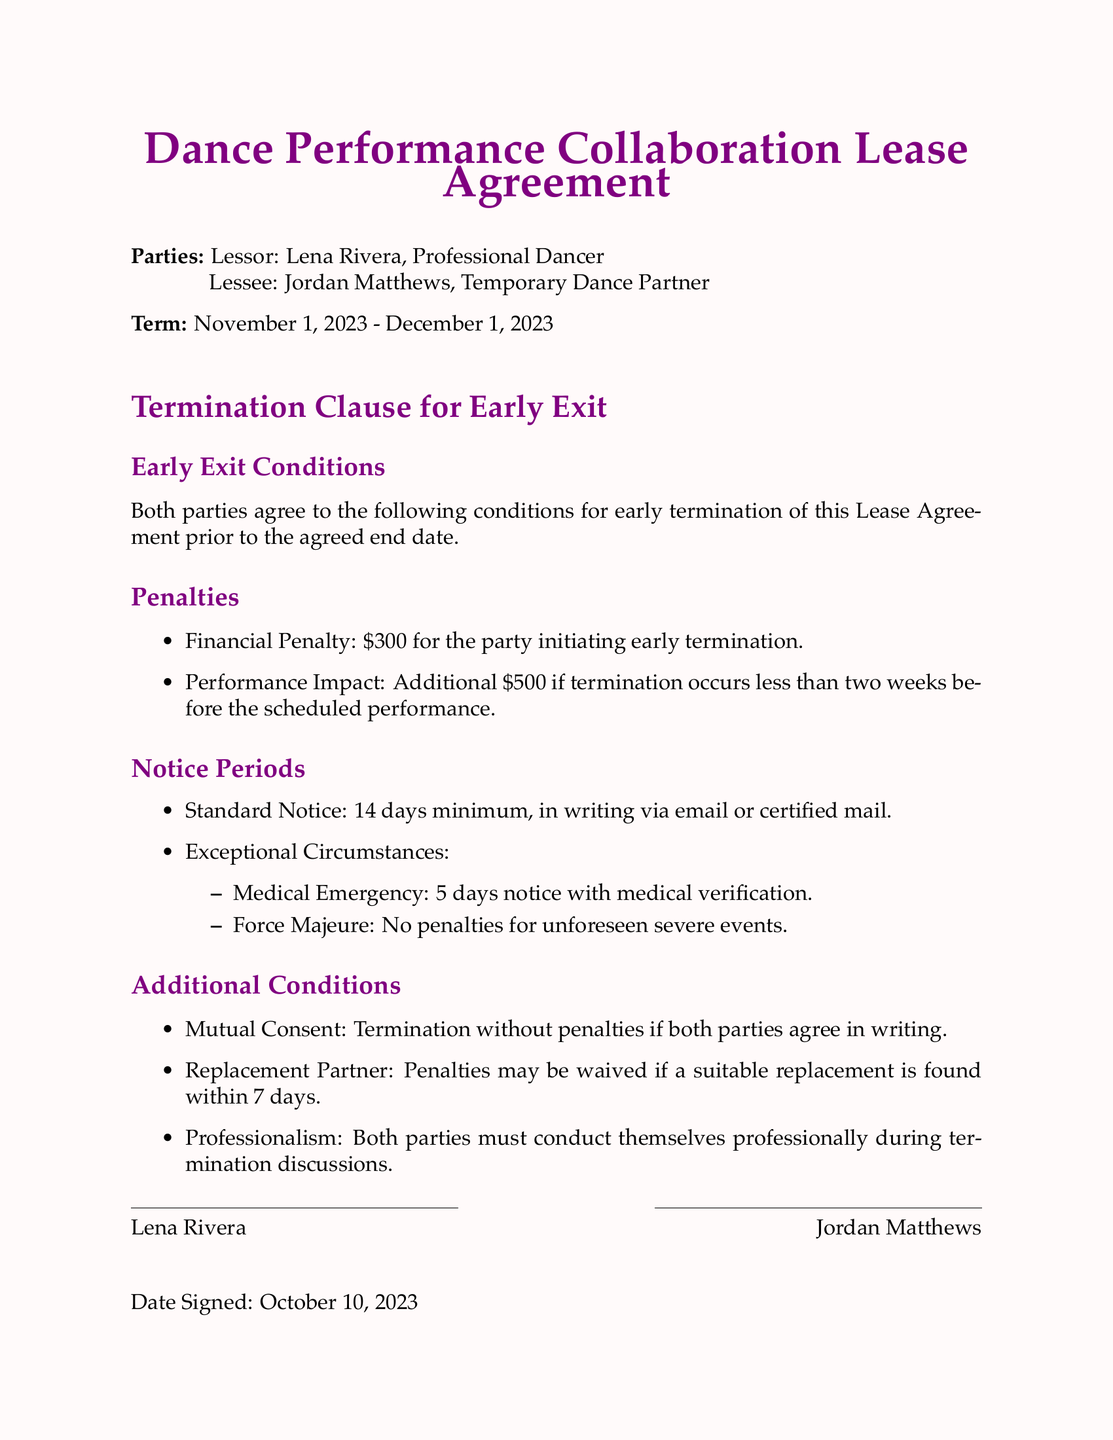What is the financial penalty for early termination? The financial penalty for the party initiating early termination is specified in the document.
Answer: $300 What is the notice period required for standard termination? The document outlines the minimum notice period required for standard termination.
Answer: 14 days Who are the parties involved in the lease agreement? The document identifies the parties involved in the lease agreement by name.
Answer: Lena Rivera and Jordan Matthews What is the penalty if termination occurs less than two weeks before the performance? The document details the additional penalty for termination occurring close to the performance date.
Answer: $500 What condition allows termination without penalties? The document specifies a condition under which termination can occur without penalties.
Answer: Mutual Consent What is the notice period required in the case of a medical emergency? The document states the notice period in the event of a medical emergency.
Answer: 5 days When was the lease agreement signed? The date when the lease agreement was signed is clearly stated in the document.
Answer: October 10, 2023 What is the duration of the lease term? The document provides the start and end dates for the lease term.
Answer: November 1, 2023 - December 1, 2023 What must both parties do during termination discussions? The document mentions a requirement for the conduct of both parties during termination discussions.
Answer: Professionalism 